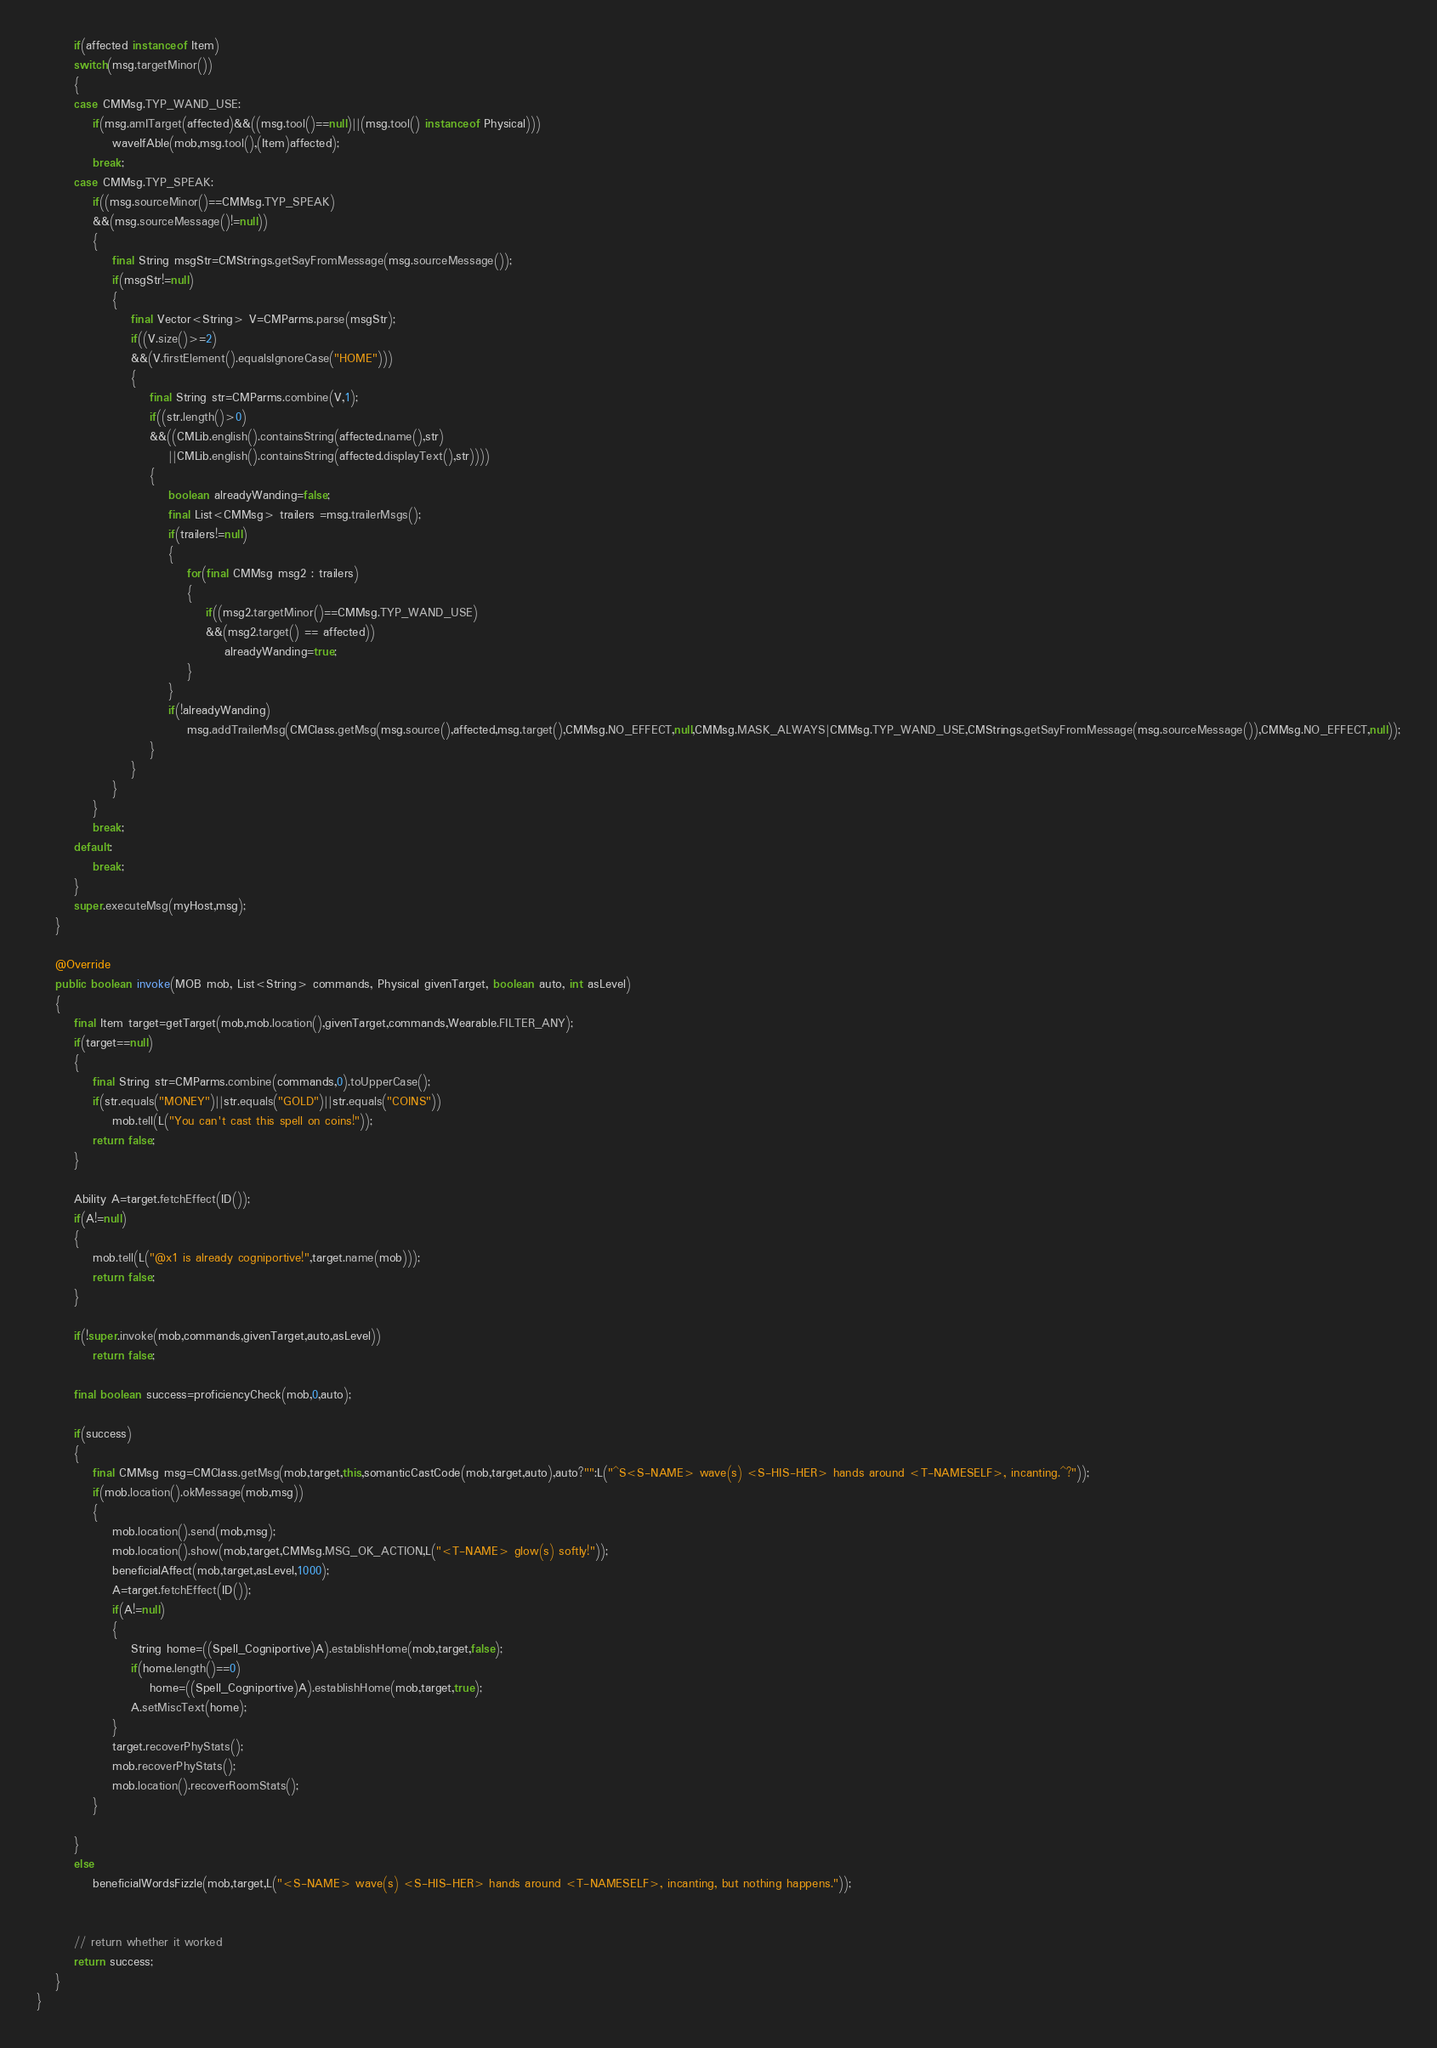Convert code to text. <code><loc_0><loc_0><loc_500><loc_500><_Java_>		if(affected instanceof Item)
		switch(msg.targetMinor())
		{
		case CMMsg.TYP_WAND_USE:
			if(msg.amITarget(affected)&&((msg.tool()==null)||(msg.tool() instanceof Physical)))
				waveIfAble(mob,msg.tool(),(Item)affected);
			break;
		case CMMsg.TYP_SPEAK:
			if((msg.sourceMinor()==CMMsg.TYP_SPEAK)
			&&(msg.sourceMessage()!=null))
			{
				final String msgStr=CMStrings.getSayFromMessage(msg.sourceMessage());
				if(msgStr!=null)
				{
					final Vector<String> V=CMParms.parse(msgStr);
					if((V.size()>=2)
					&&(V.firstElement().equalsIgnoreCase("HOME")))
					{
						final String str=CMParms.combine(V,1);
						if((str.length()>0)
						&&((CMLib.english().containsString(affected.name(),str)
							||CMLib.english().containsString(affected.displayText(),str))))
						{
							boolean alreadyWanding=false;
							final List<CMMsg> trailers =msg.trailerMsgs();
							if(trailers!=null)
							{
								for(final CMMsg msg2 : trailers)
								{
									if((msg2.targetMinor()==CMMsg.TYP_WAND_USE)
									&&(msg2.target() == affected))
										alreadyWanding=true;
								}
							}
							if(!alreadyWanding)
								msg.addTrailerMsg(CMClass.getMsg(msg.source(),affected,msg.target(),CMMsg.NO_EFFECT,null,CMMsg.MASK_ALWAYS|CMMsg.TYP_WAND_USE,CMStrings.getSayFromMessage(msg.sourceMessage()),CMMsg.NO_EFFECT,null));
						}
					}
				}
			}
			break;
		default:
			break;
		}
		super.executeMsg(myHost,msg);
	}

	@Override
	public boolean invoke(MOB mob, List<String> commands, Physical givenTarget, boolean auto, int asLevel)
	{
		final Item target=getTarget(mob,mob.location(),givenTarget,commands,Wearable.FILTER_ANY);
		if(target==null)
		{
			final String str=CMParms.combine(commands,0).toUpperCase();
			if(str.equals("MONEY")||str.equals("GOLD")||str.equals("COINS"))
				mob.tell(L("You can't cast this spell on coins!"));
			return false;
		}

		Ability A=target.fetchEffect(ID());
		if(A!=null)
		{
			mob.tell(L("@x1 is already cogniportive!",target.name(mob)));
			return false;
		}

		if(!super.invoke(mob,commands,givenTarget,auto,asLevel))
			return false;

		final boolean success=proficiencyCheck(mob,0,auto);

		if(success)
		{
			final CMMsg msg=CMClass.getMsg(mob,target,this,somanticCastCode(mob,target,auto),auto?"":L("^S<S-NAME> wave(s) <S-HIS-HER> hands around <T-NAMESELF>, incanting.^?"));
			if(mob.location().okMessage(mob,msg))
			{
				mob.location().send(mob,msg);
				mob.location().show(mob,target,CMMsg.MSG_OK_ACTION,L("<T-NAME> glow(s) softly!"));
				beneficialAffect(mob,target,asLevel,1000);
				A=target.fetchEffect(ID());
				if(A!=null)
				{
					String home=((Spell_Cogniportive)A).establishHome(mob,target,false);
					if(home.length()==0)
						home=((Spell_Cogniportive)A).establishHome(mob,target,true);
					A.setMiscText(home);
				}
				target.recoverPhyStats();
				mob.recoverPhyStats();
				mob.location().recoverRoomStats();
			}

		}
		else
			beneficialWordsFizzle(mob,target,L("<S-NAME> wave(s) <S-HIS-HER> hands around <T-NAMESELF>, incanting, but nothing happens."));


		// return whether it worked
		return success;
	}
}
</code> 